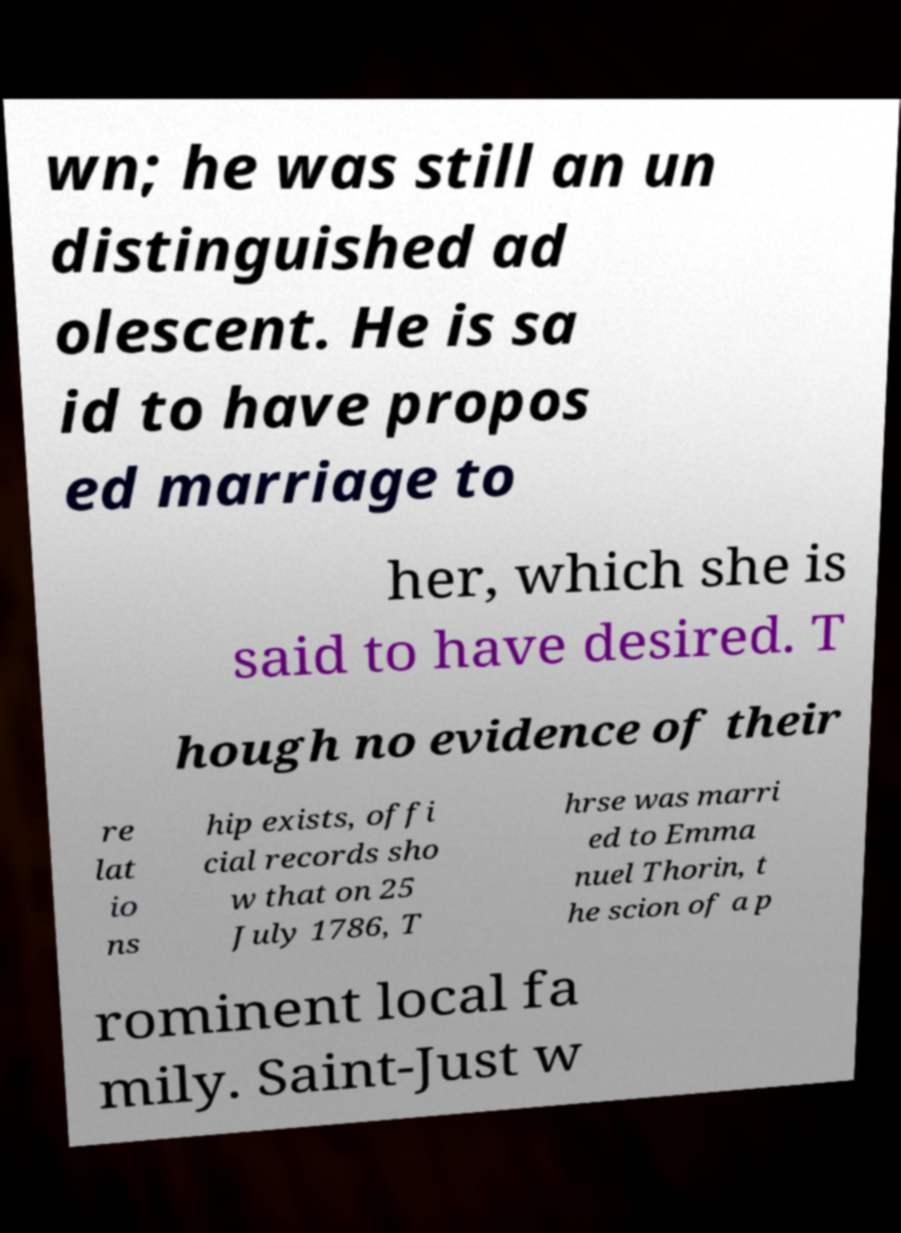For documentation purposes, I need the text within this image transcribed. Could you provide that? wn; he was still an un distinguished ad olescent. He is sa id to have propos ed marriage to her, which she is said to have desired. T hough no evidence of their re lat io ns hip exists, offi cial records sho w that on 25 July 1786, T hrse was marri ed to Emma nuel Thorin, t he scion of a p rominent local fa mily. Saint-Just w 